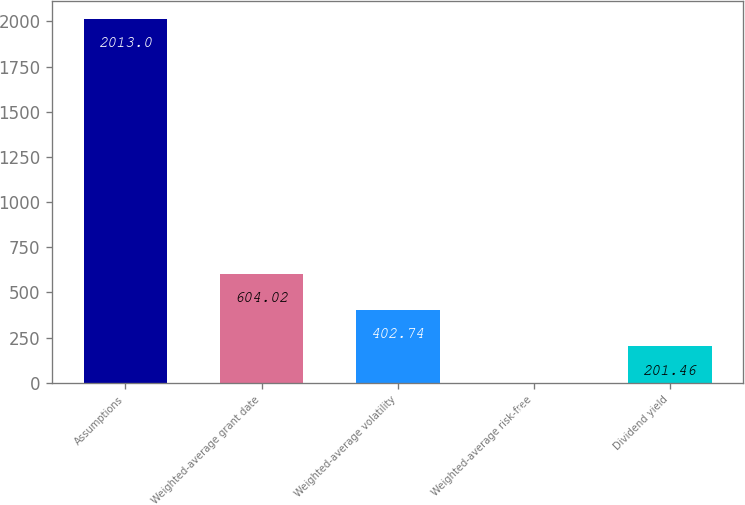<chart> <loc_0><loc_0><loc_500><loc_500><bar_chart><fcel>Assumptions<fcel>Weighted-average grant date<fcel>Weighted-average volatility<fcel>Weighted-average risk-free<fcel>Dividend yield<nl><fcel>2013<fcel>604.02<fcel>402.74<fcel>0.18<fcel>201.46<nl></chart> 